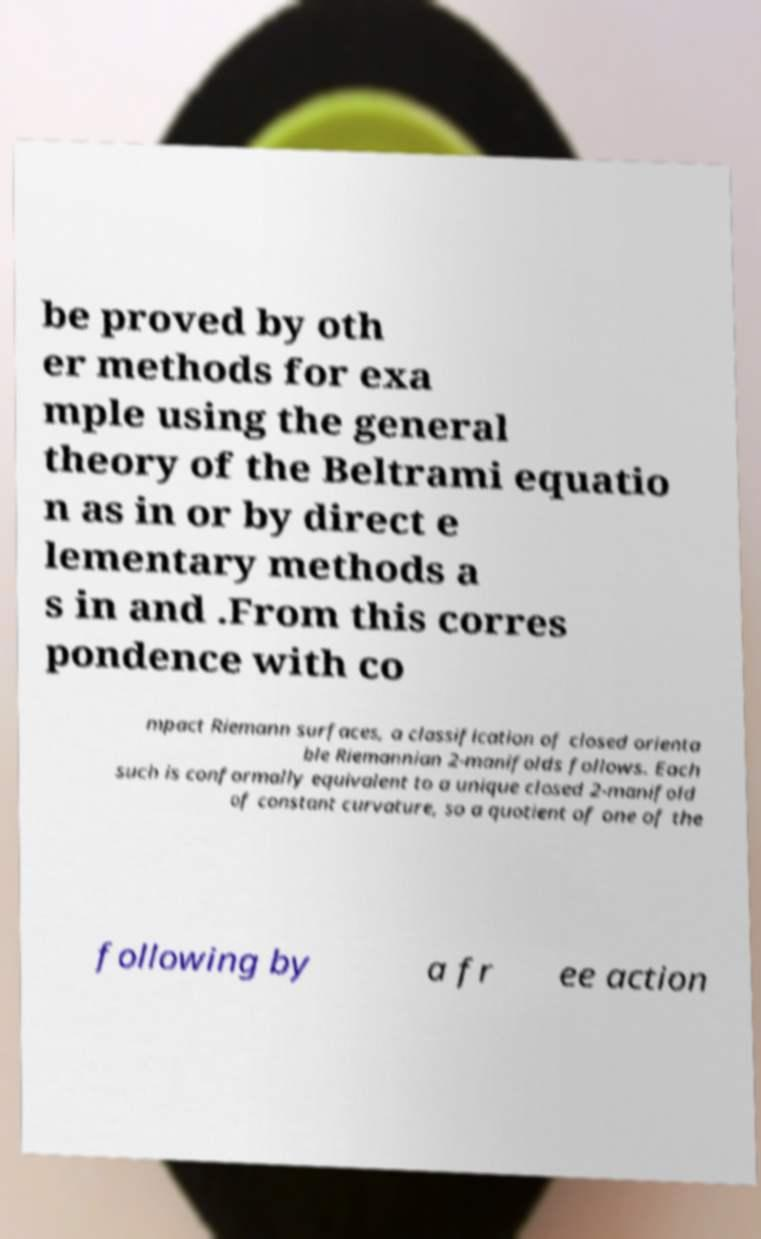There's text embedded in this image that I need extracted. Can you transcribe it verbatim? be proved by oth er methods for exa mple using the general theory of the Beltrami equatio n as in or by direct e lementary methods a s in and .From this corres pondence with co mpact Riemann surfaces, a classification of closed orienta ble Riemannian 2-manifolds follows. Each such is conformally equivalent to a unique closed 2-manifold of constant curvature, so a quotient of one of the following by a fr ee action 